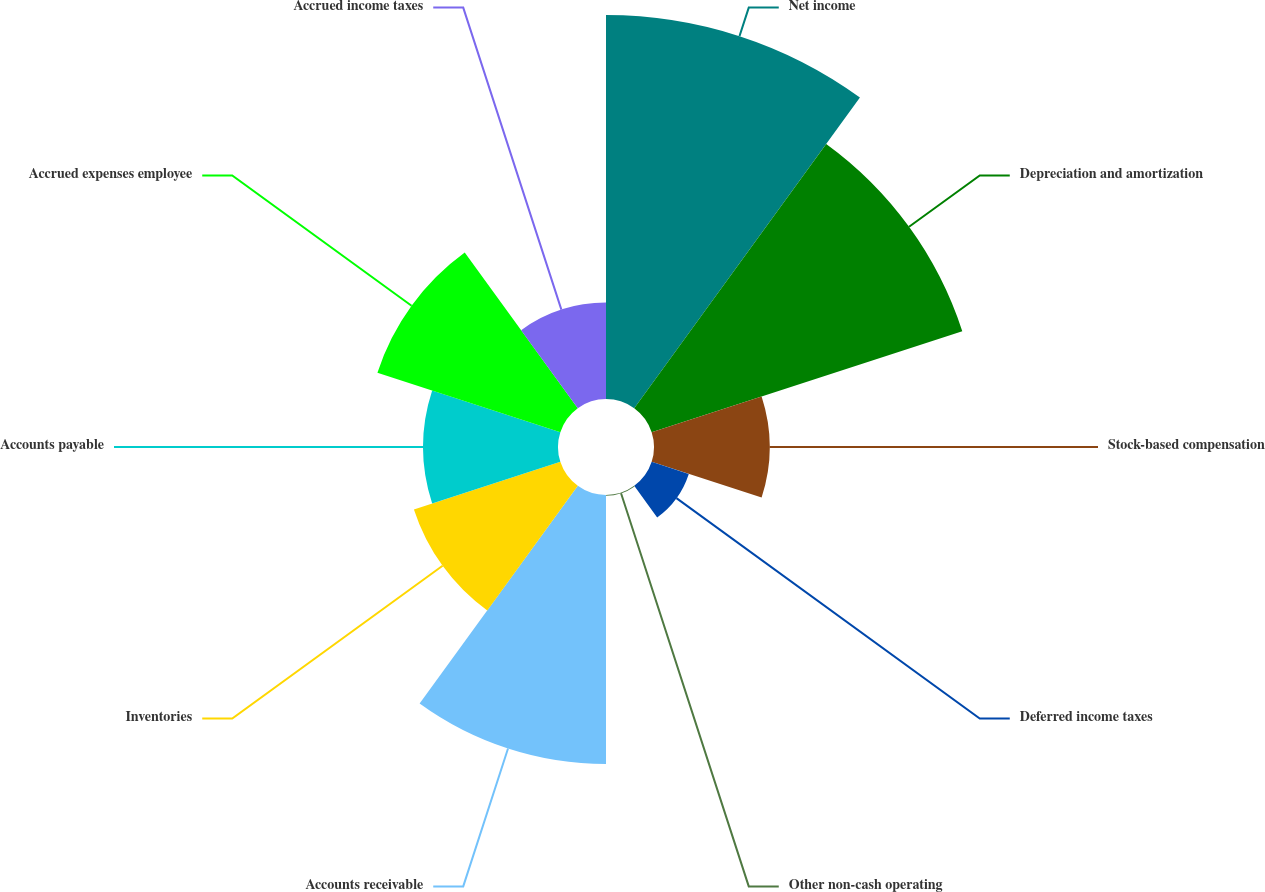Convert chart to OTSL. <chart><loc_0><loc_0><loc_500><loc_500><pie_chart><fcel>Net income<fcel>Depreciation and amortization<fcel>Stock-based compensation<fcel>Deferred income taxes<fcel>Other non-cash operating<fcel>Accounts receivable<fcel>Inventories<fcel>Accounts payable<fcel>Accrued expenses employee<fcel>Accrued income taxes<nl><fcel>22.42%<fcel>19.07%<fcel>6.75%<fcel>2.28%<fcel>0.04%<fcel>15.71%<fcel>8.99%<fcel>7.87%<fcel>11.23%<fcel>5.63%<nl></chart> 